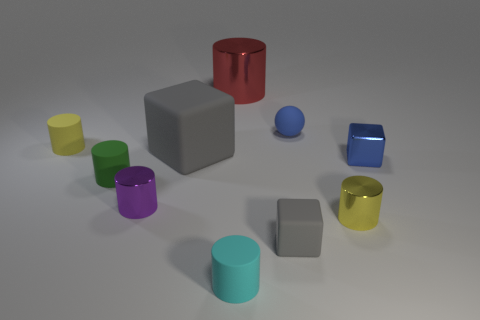Subtract all tiny green matte cylinders. How many cylinders are left? 5 Subtract all purple balls. How many gray cubes are left? 2 Subtract all yellow cylinders. How many cylinders are left? 4 Subtract all green things. Subtract all yellow rubber things. How many objects are left? 8 Add 6 tiny blue things. How many tiny blue things are left? 8 Add 9 tiny purple objects. How many tiny purple objects exist? 10 Subtract 0 yellow balls. How many objects are left? 10 Subtract all balls. How many objects are left? 9 Subtract 3 blocks. How many blocks are left? 0 Subtract all cyan cylinders. Subtract all green balls. How many cylinders are left? 5 